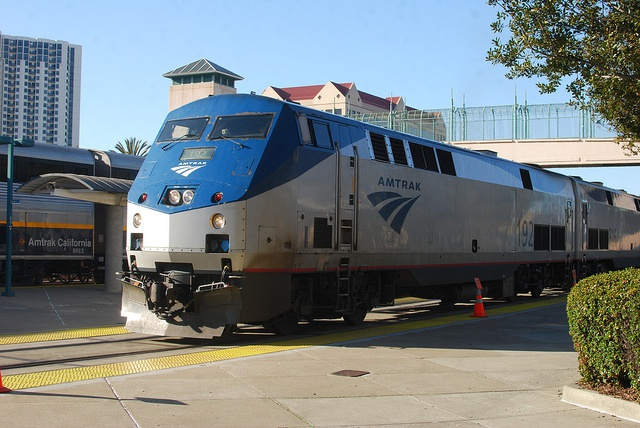Describe the objects in this image and their specific colors. I can see a train in lightblue, black, gray, blue, and navy tones in this image. 